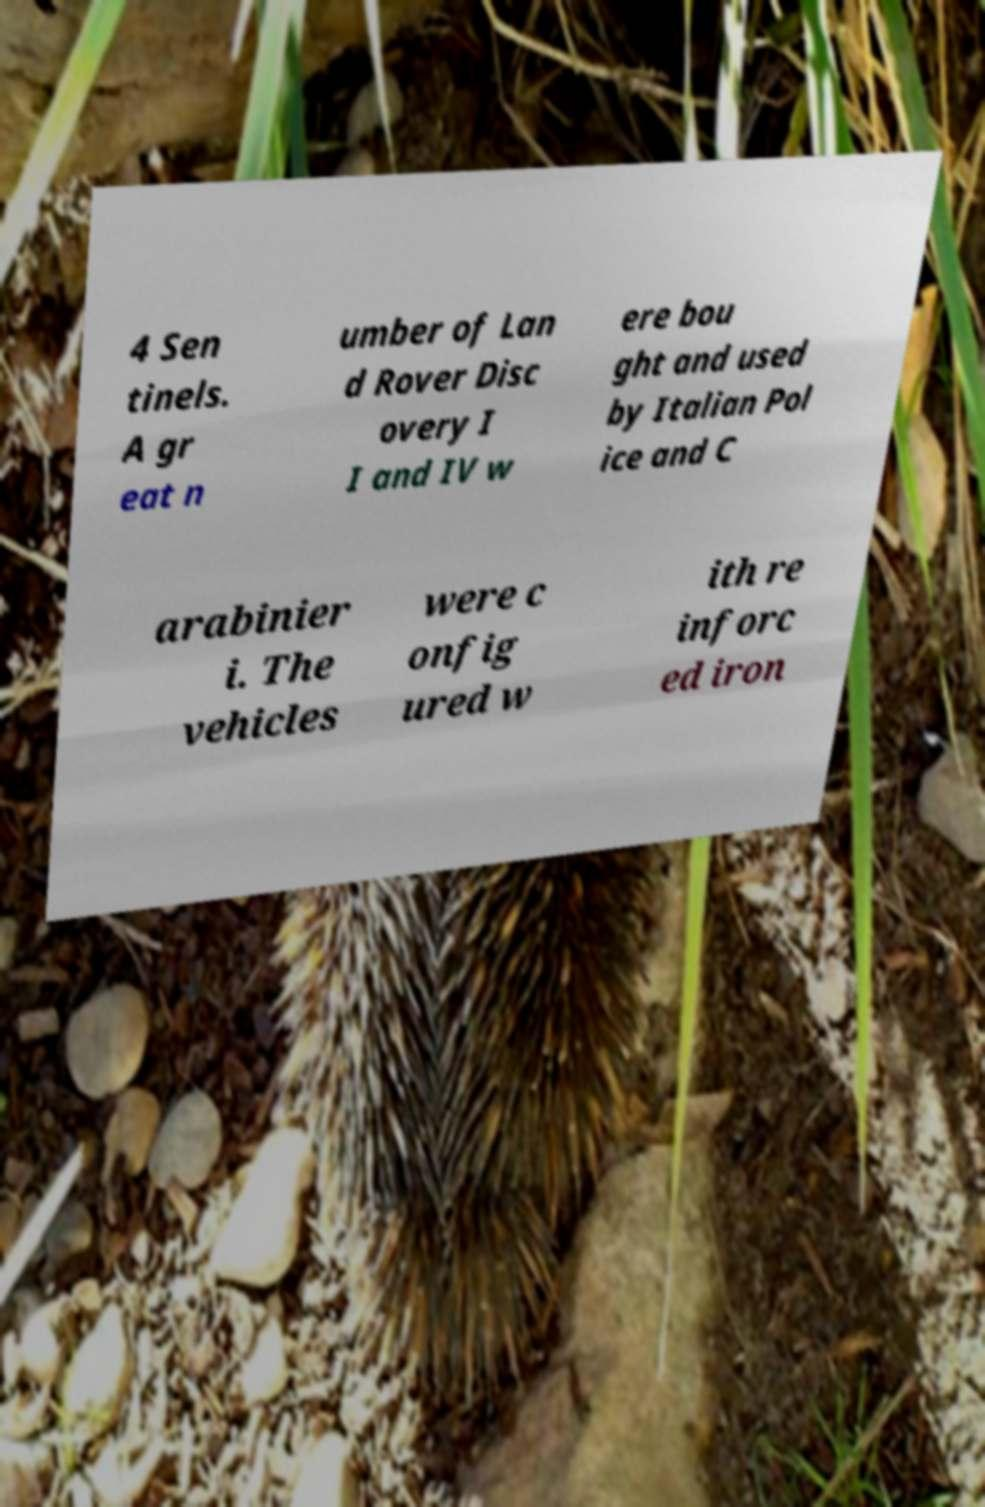Please identify and transcribe the text found in this image. 4 Sen tinels. A gr eat n umber of Lan d Rover Disc overy I I and IV w ere bou ght and used by Italian Pol ice and C arabinier i. The vehicles were c onfig ured w ith re inforc ed iron 